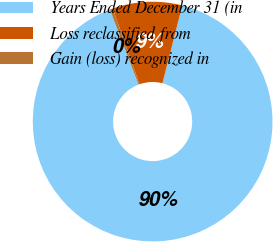Convert chart. <chart><loc_0><loc_0><loc_500><loc_500><pie_chart><fcel>Years Ended December 31 (in<fcel>Loss reclassified from<fcel>Gain (loss) recognized in<nl><fcel>90.21%<fcel>9.38%<fcel>0.4%<nl></chart> 